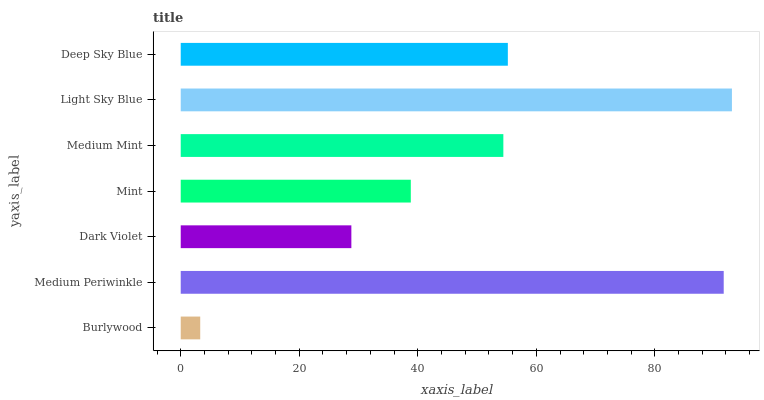Is Burlywood the minimum?
Answer yes or no. Yes. Is Light Sky Blue the maximum?
Answer yes or no. Yes. Is Medium Periwinkle the minimum?
Answer yes or no. No. Is Medium Periwinkle the maximum?
Answer yes or no. No. Is Medium Periwinkle greater than Burlywood?
Answer yes or no. Yes. Is Burlywood less than Medium Periwinkle?
Answer yes or no. Yes. Is Burlywood greater than Medium Periwinkle?
Answer yes or no. No. Is Medium Periwinkle less than Burlywood?
Answer yes or no. No. Is Medium Mint the high median?
Answer yes or no. Yes. Is Medium Mint the low median?
Answer yes or no. Yes. Is Deep Sky Blue the high median?
Answer yes or no. No. Is Dark Violet the low median?
Answer yes or no. No. 